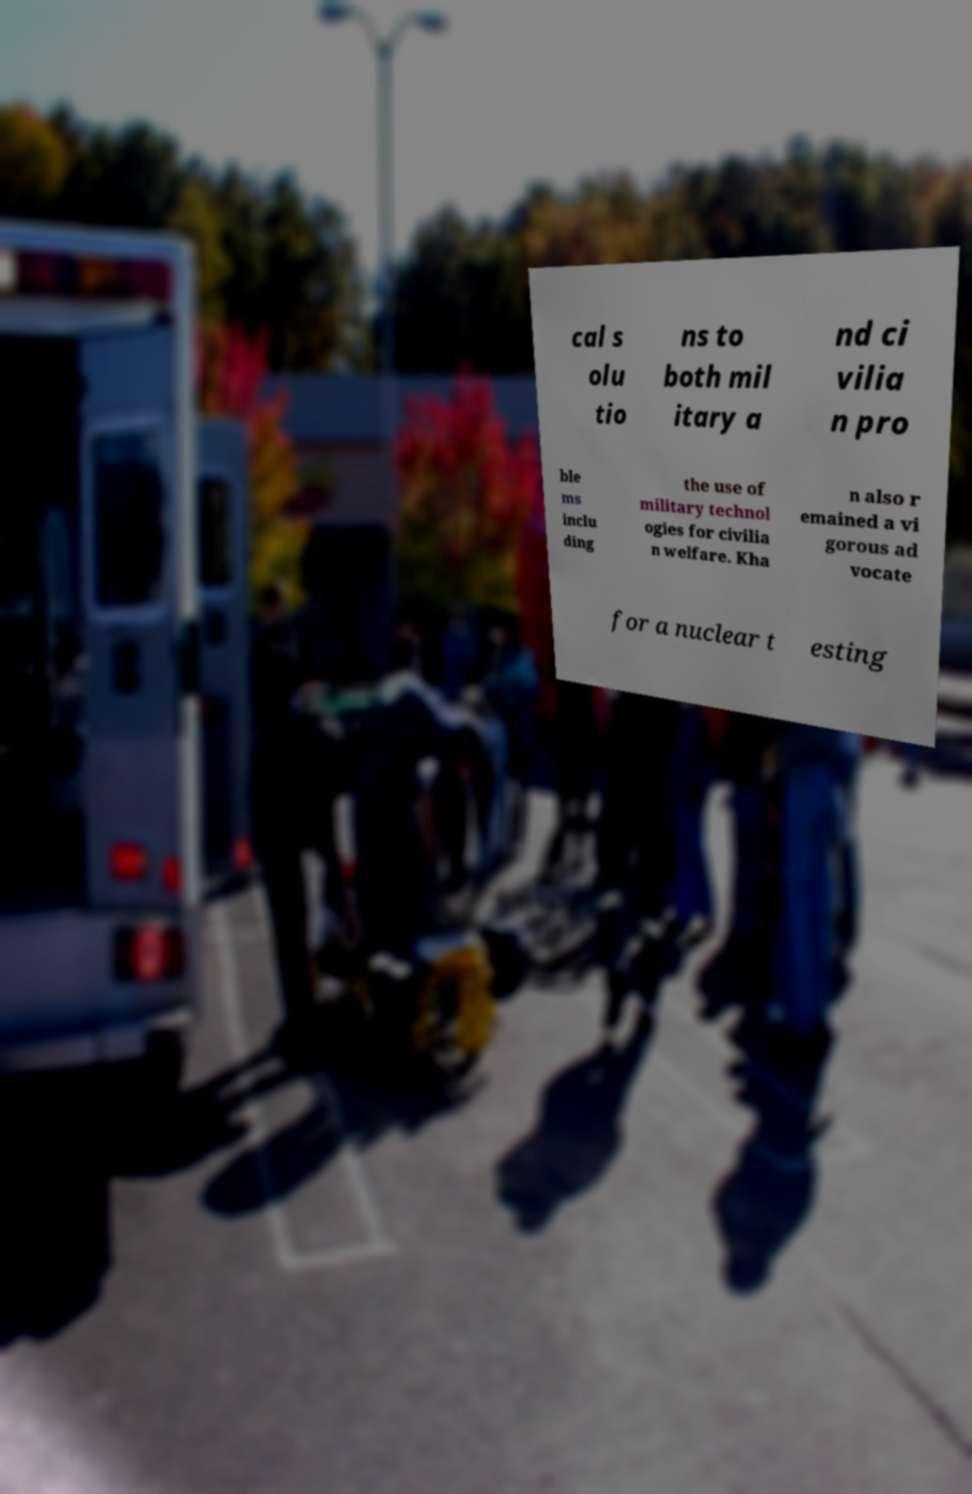Could you extract and type out the text from this image? cal s olu tio ns to both mil itary a nd ci vilia n pro ble ms inclu ding the use of military technol ogies for civilia n welfare. Kha n also r emained a vi gorous ad vocate for a nuclear t esting 